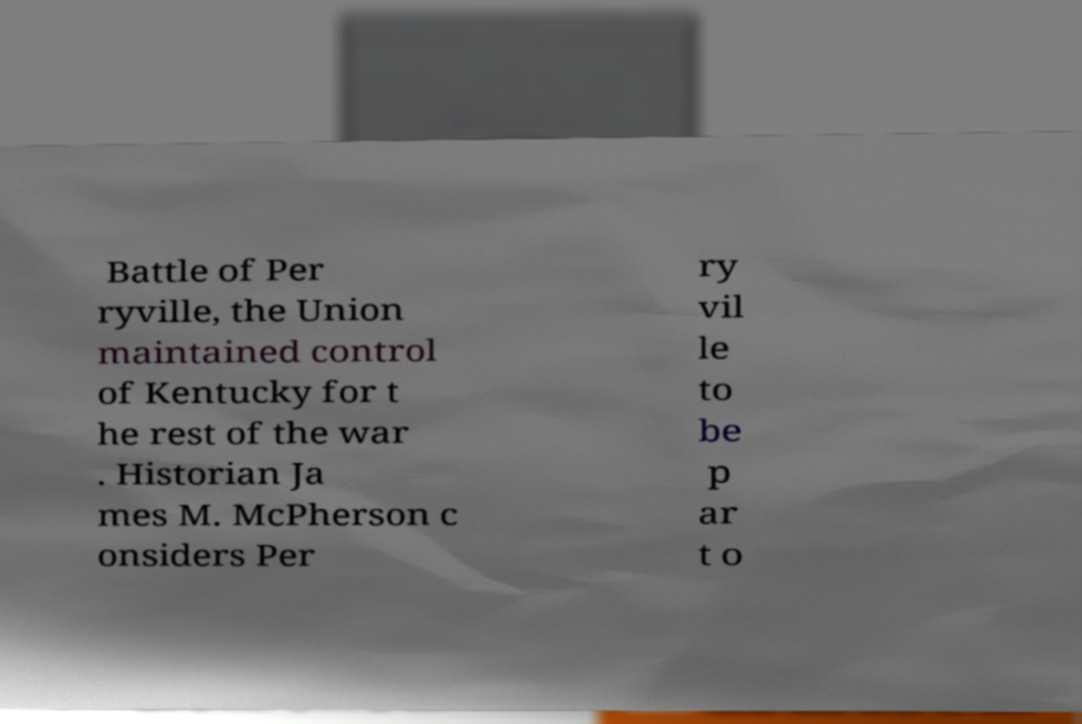Please identify and transcribe the text found in this image. Battle of Per ryville, the Union maintained control of Kentucky for t he rest of the war . Historian Ja mes M. McPherson c onsiders Per ry vil le to be p ar t o 